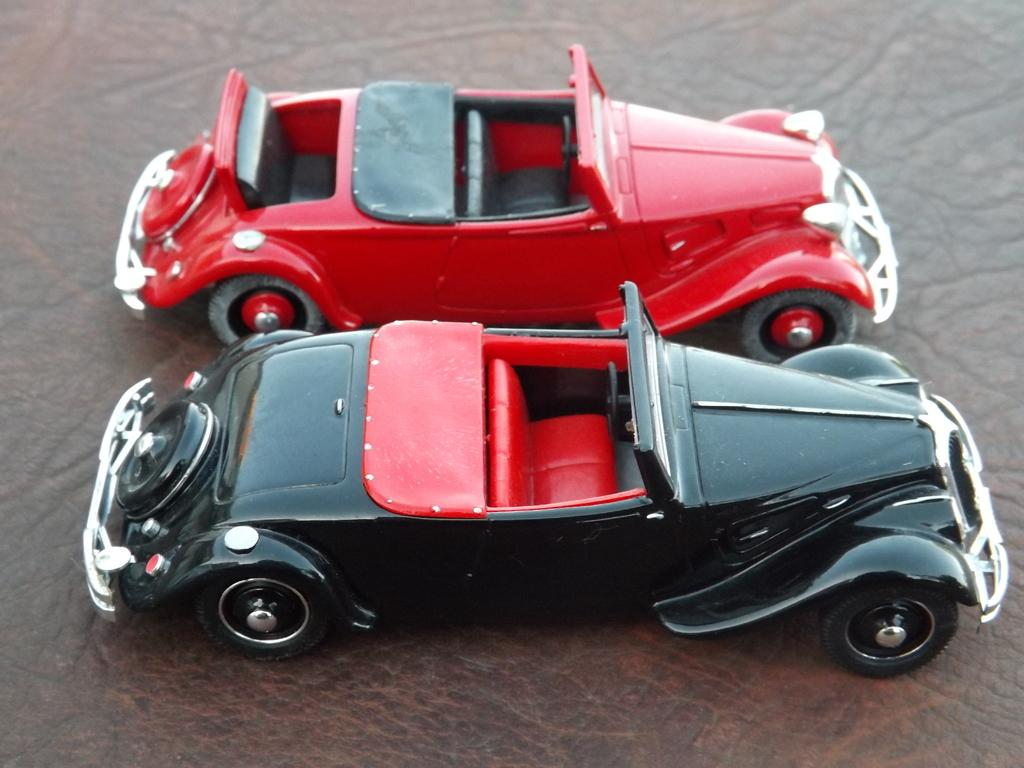What type of vehicles are in the image? There are two classic miniature cars in the image. What colors are the cars? One car is black, and the other is red. Where are the cars located in the image? The cars are placed on a table. Is there a maid in the image making a statement about the border? There is no maid or statement about a border present in the image; it features two classic miniature cars placed on a table. 